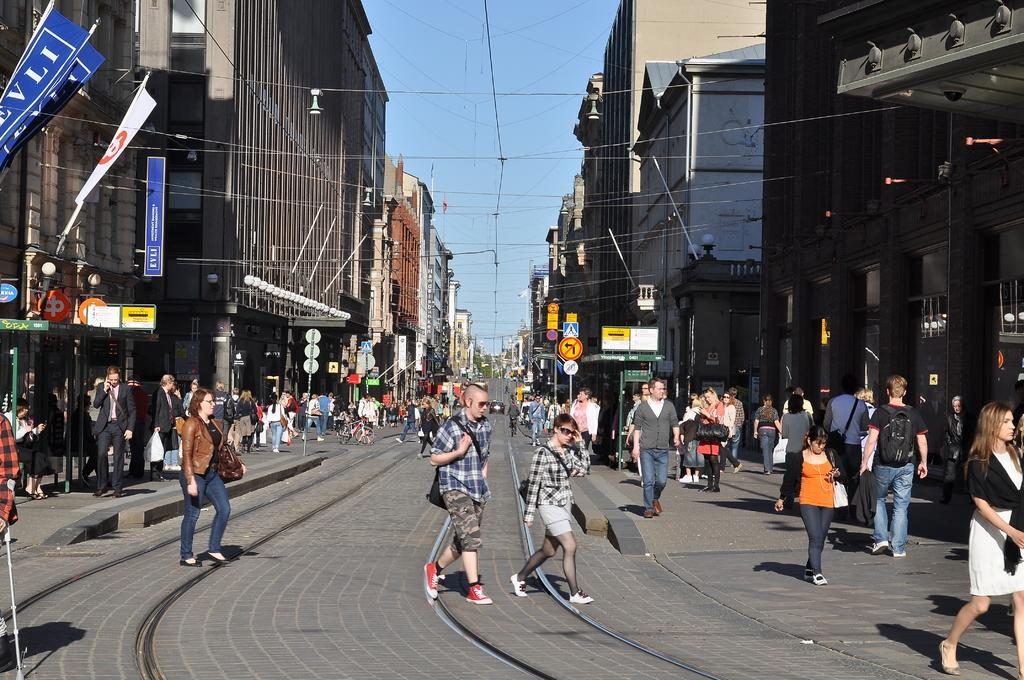What type of structures can be seen in the image? There are buildings in the image. What feature do the buildings have? The buildings have lights. What other objects are present in the image? There are flags, posters, a road, people, a rail track, more posters, poles, sign boards, and the sky is visible in the image. What type of insect can be seen crawling on the salt in the image? There is no insect or salt present in the image. What type of rat can be seen interacting with the sign boards in the image? There is no rat present in the image. 